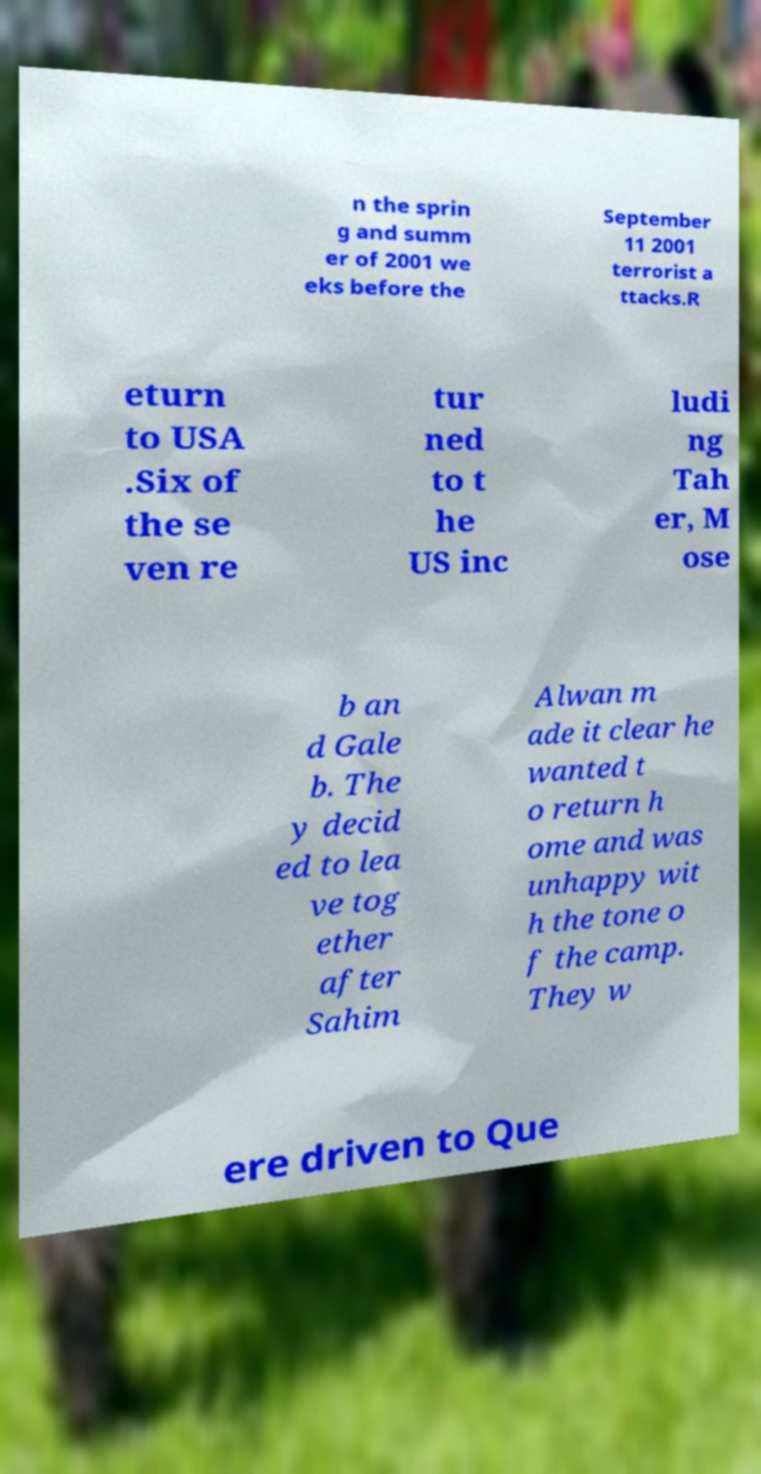What messages or text are displayed in this image? I need them in a readable, typed format. n the sprin g and summ er of 2001 we eks before the September 11 2001 terrorist a ttacks.R eturn to USA .Six of the se ven re tur ned to t he US inc ludi ng Tah er, M ose b an d Gale b. The y decid ed to lea ve tog ether after Sahim Alwan m ade it clear he wanted t o return h ome and was unhappy wit h the tone o f the camp. They w ere driven to Que 